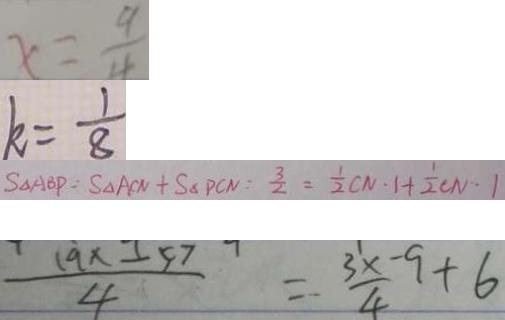Convert formula to latex. <formula><loc_0><loc_0><loc_500><loc_500>x = \frac { 9 } { 4 } 
 k = \frac { 1 } { 8 } 
 S _ { \Delta } A B P : S _ { \Delta } A C N + S _ { \Delta } P C N = \frac { 3 } { 2 } = \frac { 1 } { 2 } C N \cdot 1 + \frac { 1 } { 2 } C N \cdot 1 
 \frac { 1 9 x - 5 7 } { 4 } = \frac { 3 x - 9 + 6 } { 4 }</formula> 